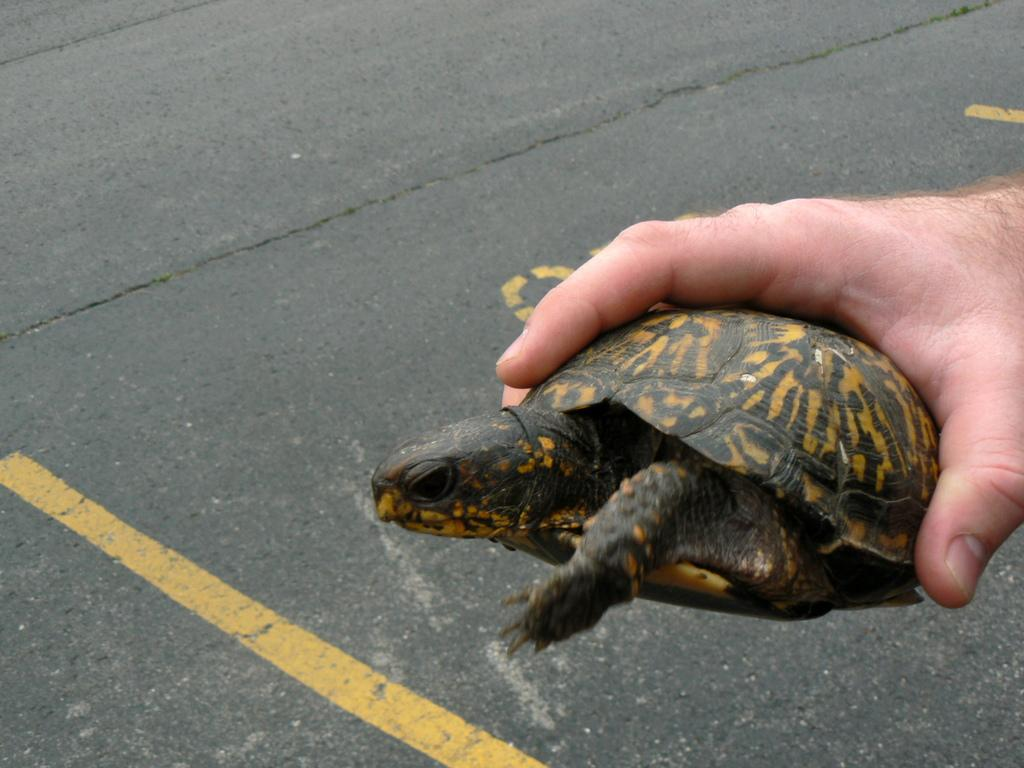What is the human hand holding in the image? The human hand is holding a tortoise in the image. What can be seen in the background of the image? There is a road in the background of the image. What are the yellow lines on the road used for? The yellow lines on the road are used to separate traffic lanes. What is written on the road? There is text on the road, which might indicate road markings or signs. Where is the hospital located in the image? There is no hospital present in the image. What type of patch is sewn onto the tortoise's shell in the image? There is no patch or any sewing activity visible on the tortoise's shell in the image. 